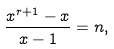Convert formula to latex. <formula><loc_0><loc_0><loc_500><loc_500>\frac { x ^ { r + 1 } - x } { x - 1 } = n ,</formula> 